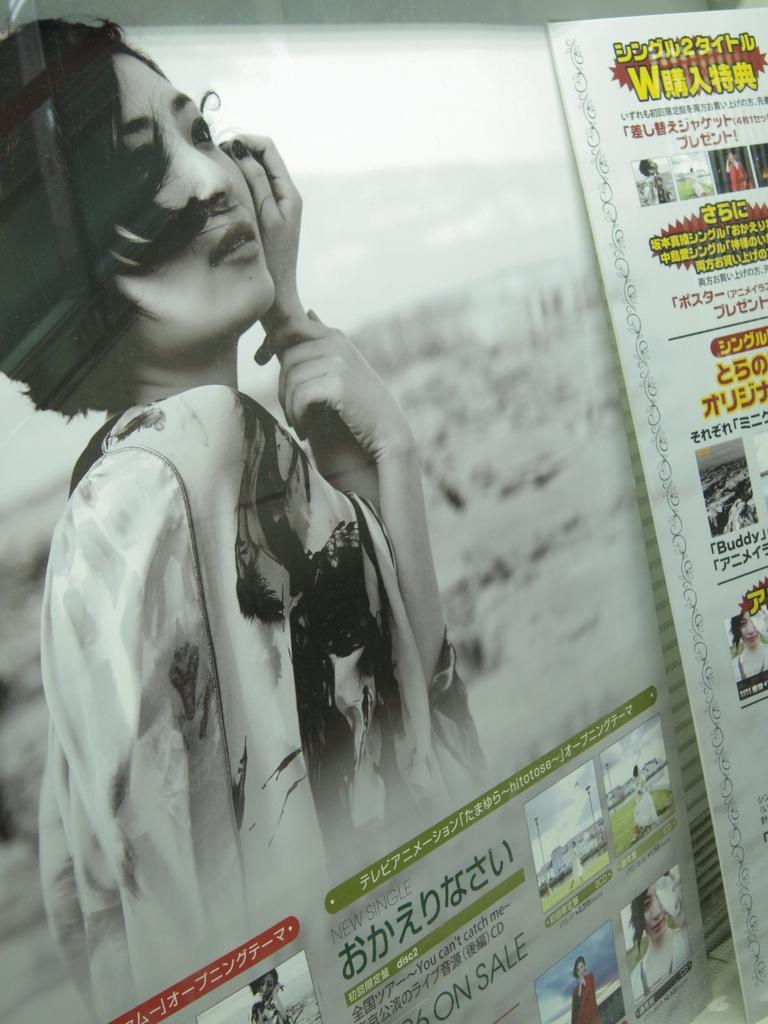What objects are present in the image that support something? There are posts in the image that support something. What is attached to the posts? The posts have posters on them. What can be seen on the posters? There are people depicted on the posters, as well as text. Can you tell me how many mittens are shown on the posters? There are no mittens depicted on the posters; they feature people and text. 